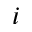Convert formula to latex. <formula><loc_0><loc_0><loc_500><loc_500>i</formula> 